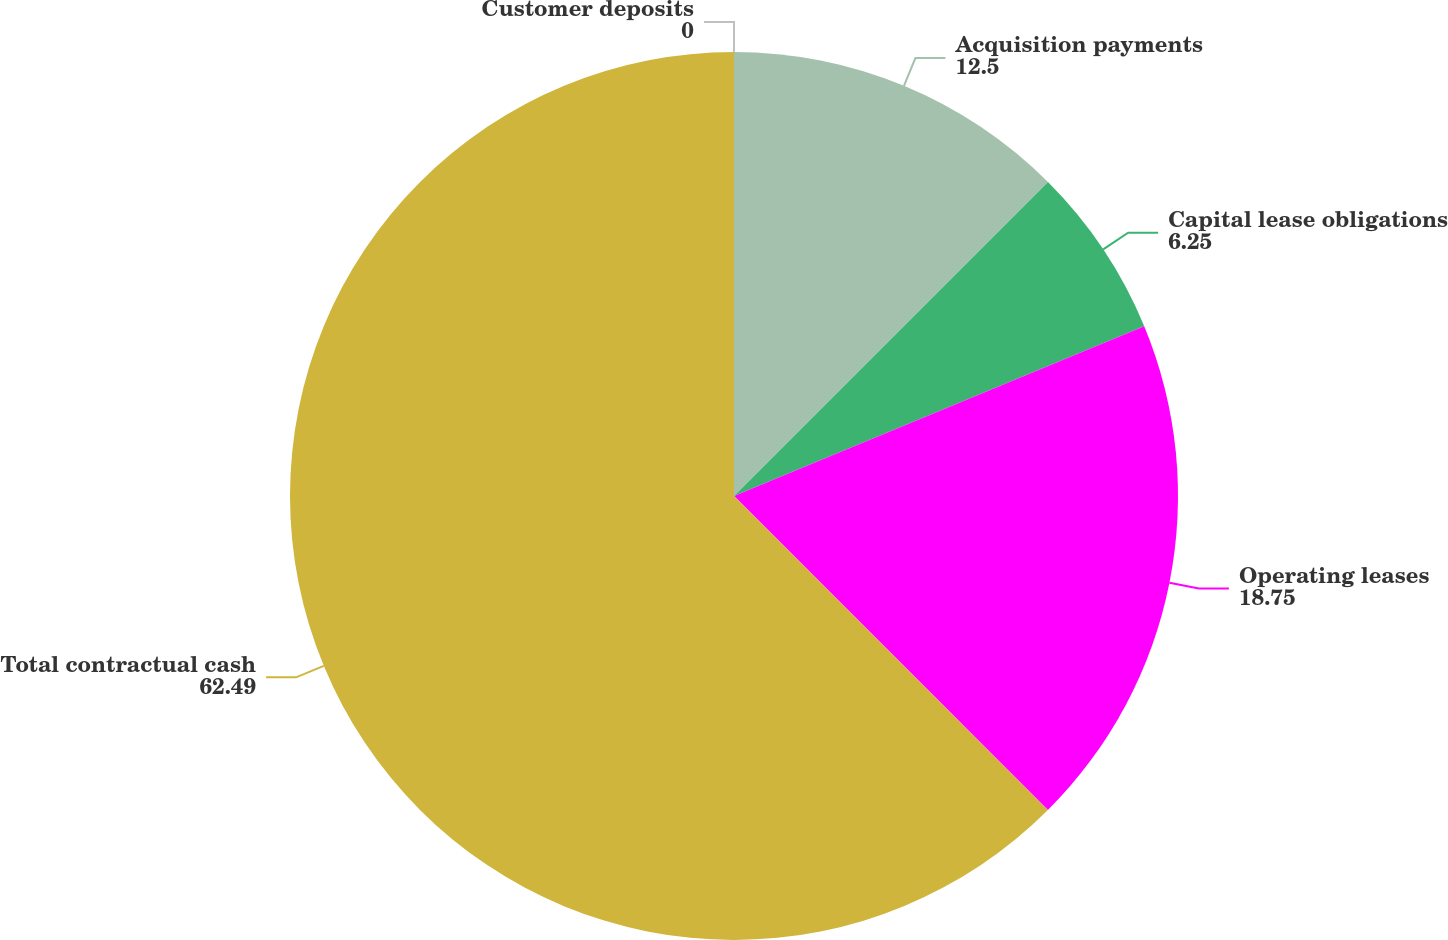<chart> <loc_0><loc_0><loc_500><loc_500><pie_chart><fcel>Customer deposits<fcel>Acquisition payments<fcel>Capital lease obligations<fcel>Operating leases<fcel>Total contractual cash<nl><fcel>0.0%<fcel>12.5%<fcel>6.25%<fcel>18.75%<fcel>62.49%<nl></chart> 